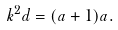<formula> <loc_0><loc_0><loc_500><loc_500>k ^ { 2 } d = ( a + 1 ) a .</formula> 